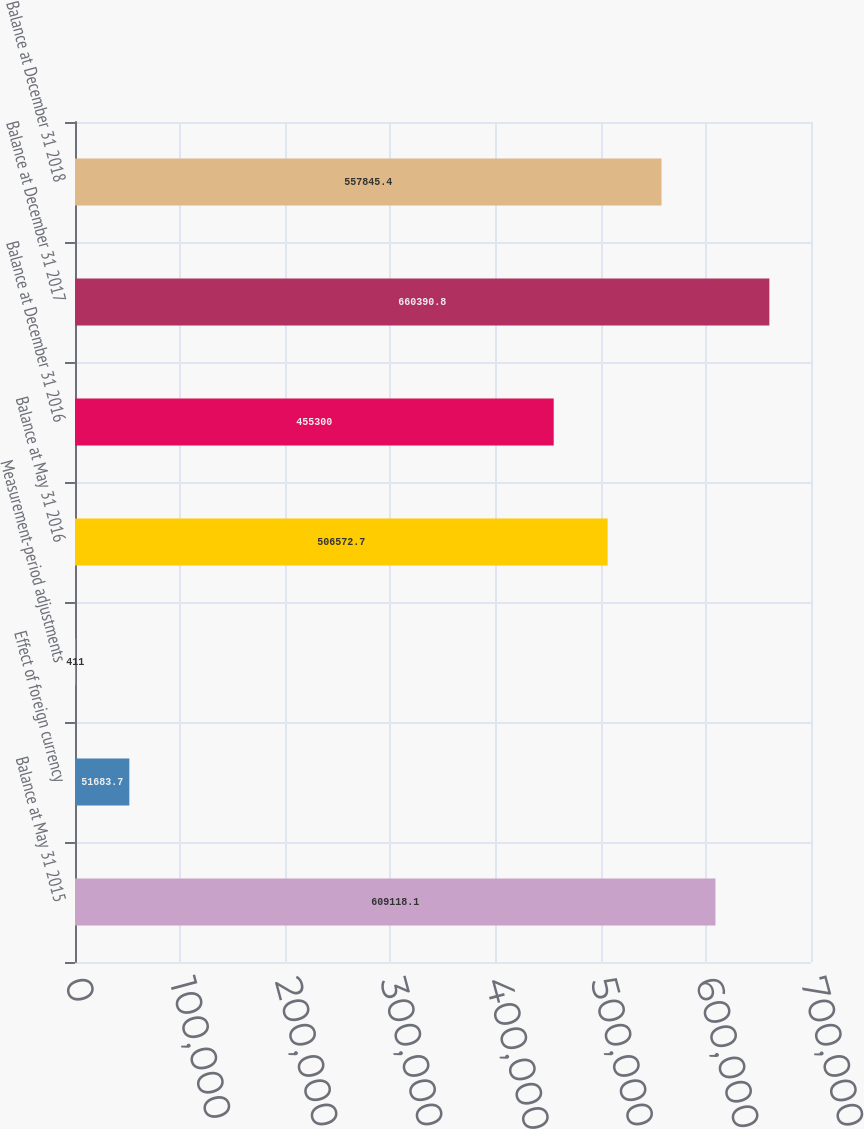Convert chart to OTSL. <chart><loc_0><loc_0><loc_500><loc_500><bar_chart><fcel>Balance at May 31 2015<fcel>Effect of foreign currency<fcel>Measurement-period adjustments<fcel>Balance at May 31 2016<fcel>Balance at December 31 2016<fcel>Balance at December 31 2017<fcel>Balance at December 31 2018<nl><fcel>609118<fcel>51683.7<fcel>411<fcel>506573<fcel>455300<fcel>660391<fcel>557845<nl></chart> 